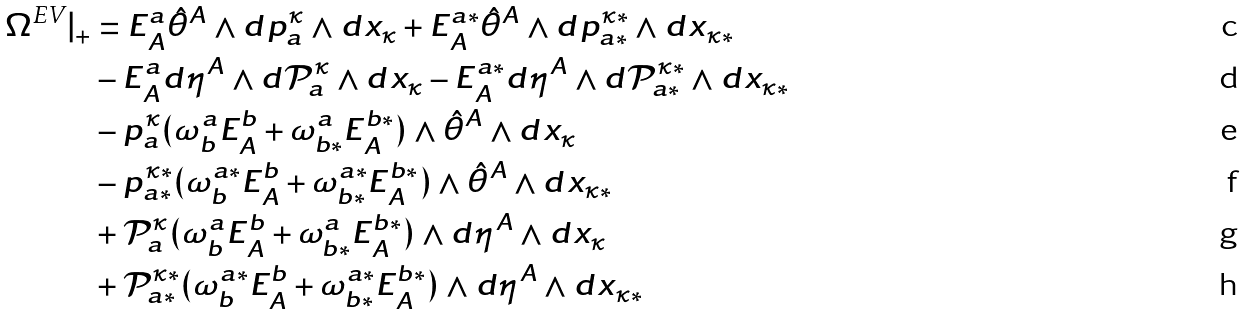<formula> <loc_0><loc_0><loc_500><loc_500>\Omega ^ { \text {EV} } | _ { + } & = E _ { A } ^ { a } { \hat { \theta } } ^ { A } \wedge d p _ { a } ^ { \kappa } \wedge d x _ { \kappa } + E _ { A } ^ { a * } { \hat { \theta } } ^ { A } \wedge d p _ { a * } ^ { \kappa * } \wedge d x _ { \kappa * } \\ & - E _ { A } ^ { a } d \eta ^ { A } \wedge d \mathcal { P } _ { a } ^ { \kappa } \wedge d x _ { \kappa } - E _ { A } ^ { a * } d \eta ^ { A } \wedge d \mathcal { P } _ { a * } ^ { \kappa * } \wedge d x _ { \kappa * } \\ & - p _ { a } ^ { \kappa } ( \omega ^ { a } _ { b } E ^ { b } _ { A } + \omega ^ { a } _ { b * } E ^ { b * } _ { A } ) \wedge { \hat { \theta } } ^ { A } \wedge d x _ { \kappa } \\ & - p _ { a * } ^ { \kappa * } ( \omega ^ { a * } _ { b } E ^ { b } _ { A } + \omega ^ { a * } _ { b * } E ^ { b * } _ { A } ) \wedge { \hat { \theta } } ^ { A } \wedge d x _ { \kappa * } \\ & + \mathcal { P } _ { a } ^ { \kappa } ( \omega ^ { a } _ { b } E ^ { b } _ { A } + \omega ^ { a } _ { b * } E ^ { b * } _ { A } ) \wedge d \eta ^ { A } \wedge d x _ { \kappa } \\ & + \mathcal { P } _ { a * } ^ { \kappa * } ( \omega ^ { a * } _ { b } E ^ { b } _ { A } + \omega ^ { a * } _ { b * } E ^ { b * } _ { A } ) \wedge d \eta ^ { A } \wedge d x _ { \kappa * }</formula> 